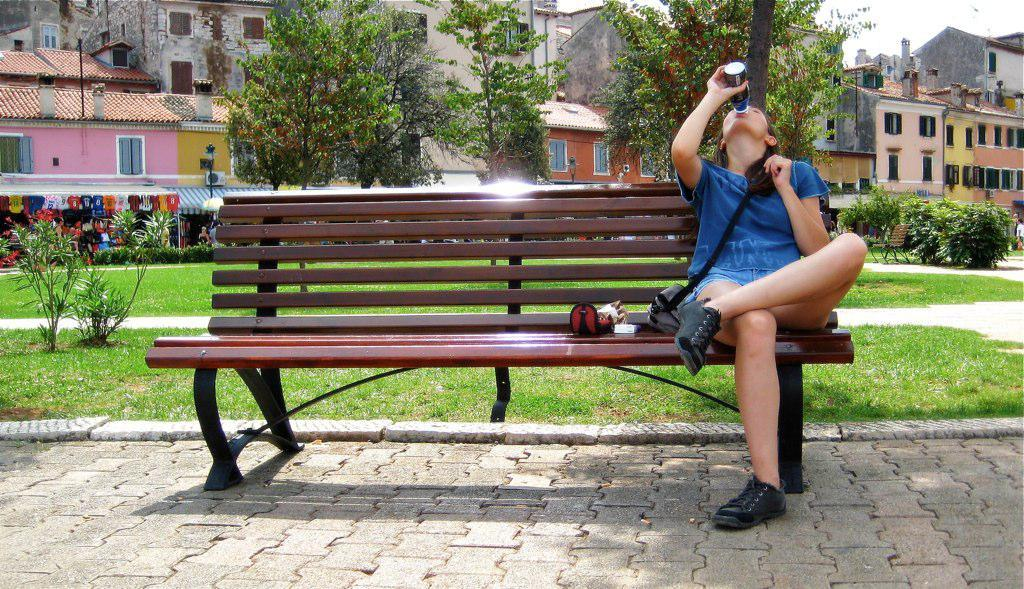What is the main subject in the foreground of the image? There is a woman sitting on a bench in the foreground of the image. What can be seen in the background of the image? There are buildings, trees, plants, grass, and the sky visible in the background of the image. How many horses are present in the image? There are no horses present in the image. What type of tax is being discussed in the image? There is no discussion of tax in the image. 